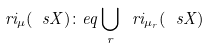Convert formula to latex. <formula><loc_0><loc_0><loc_500><loc_500>\ r i _ { \mu } ( \ s X ) \colon e q \bigcup _ { r } \ r i _ { \mu _ { r } } ( \ s X )</formula> 